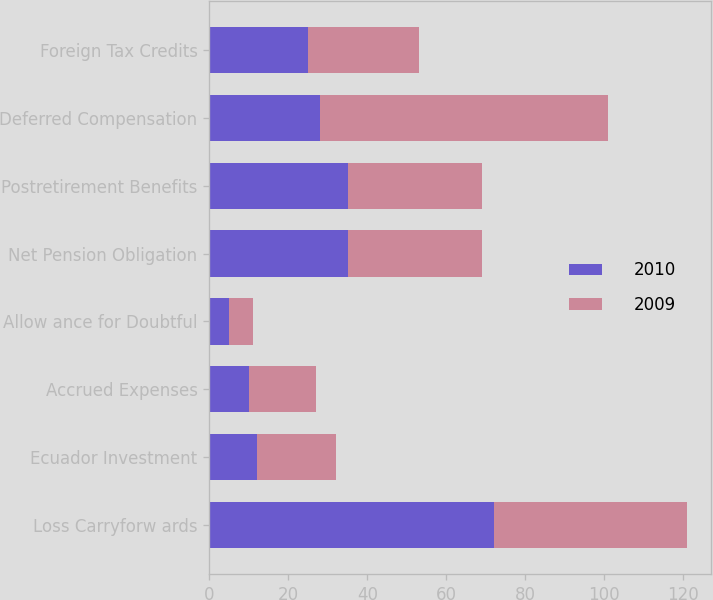<chart> <loc_0><loc_0><loc_500><loc_500><stacked_bar_chart><ecel><fcel>Loss Carryforw ards<fcel>Ecuador Investment<fcel>Accrued Expenses<fcel>Allow ance for Doubtful<fcel>Net Pension Obligation<fcel>Postretirement Benefits<fcel>Deferred Compensation<fcel>Foreign Tax Credits<nl><fcel>2010<fcel>72<fcel>12<fcel>10<fcel>5<fcel>35<fcel>35<fcel>28<fcel>25<nl><fcel>2009<fcel>49<fcel>20<fcel>17<fcel>6<fcel>34<fcel>34<fcel>73<fcel>28<nl></chart> 